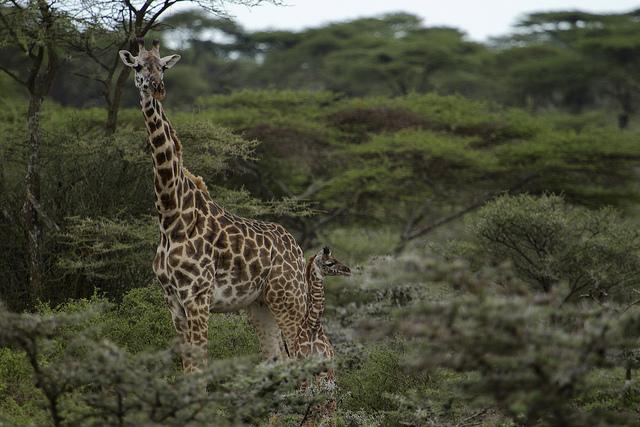Is this a forest?
Short answer required. Yes. What is in front of the giraffe?
Short answer required. Tree. How old is this giraffe?
Be succinct. 4. Are these giraffes in the wild?
Quick response, please. Yes. Can you determine the sex of the giraffe?
Be succinct. No. Is this in nature?
Write a very short answer. Yes. Is the giraffe near a lake?
Give a very brief answer. No. What type of animals are these?
Be succinct. Giraffes. Are the giraffes in captivity?
Give a very brief answer. No. How many giraffes are there?
Be succinct. 1. Is there a baby animal in this photo?
Keep it brief. Yes. 